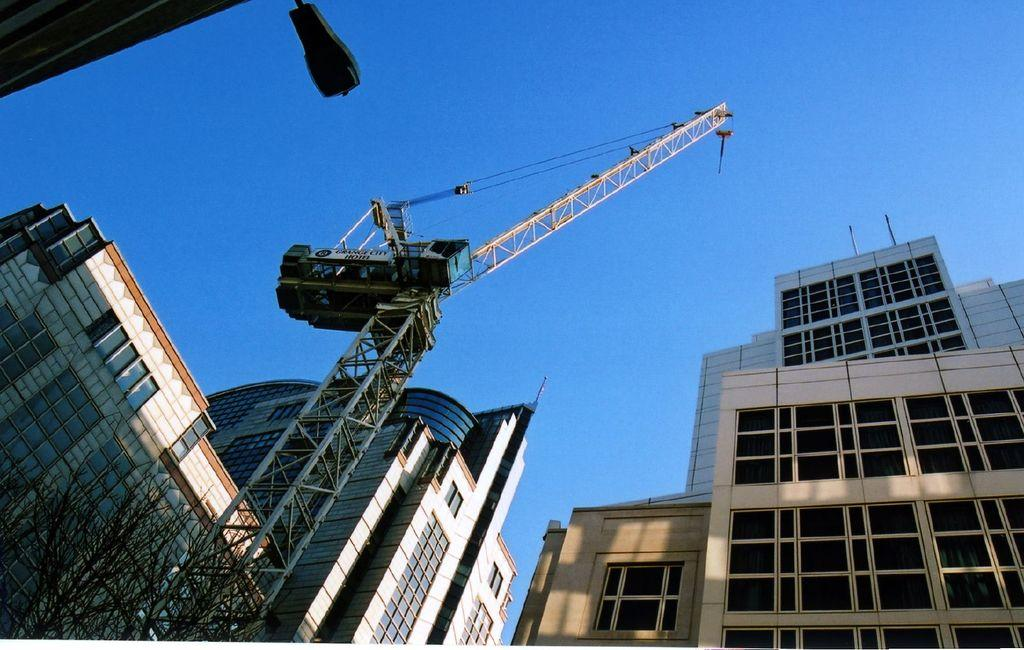What type of plant can be seen in the image? There is a tree in the image. What large machine is present in the image? There is a huge crane in the image. What type of structures are visible in the image? There are buildings in the image. What can be seen in the background of the image? The sky is visible in the background of the image. Can you see your friend using a brush to bake something in the oven in the image? There is no friend, brush, or oven present in the image. 